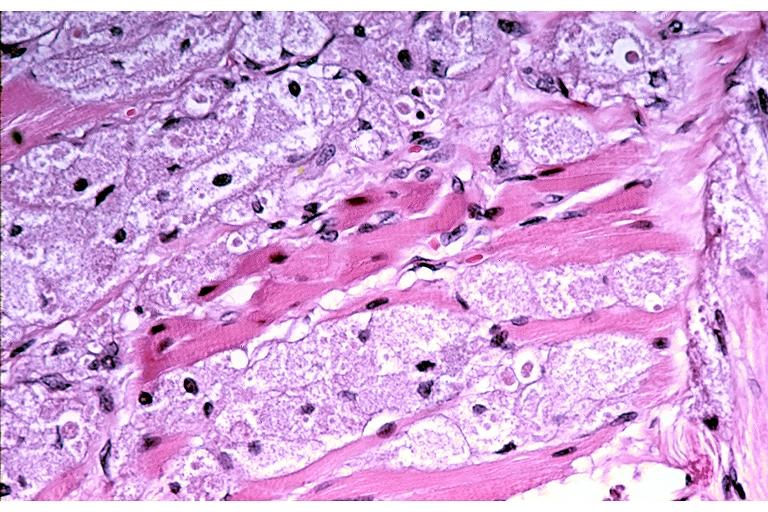what does this image show?
Answer the question using a single word or phrase. Granular cell tumor 